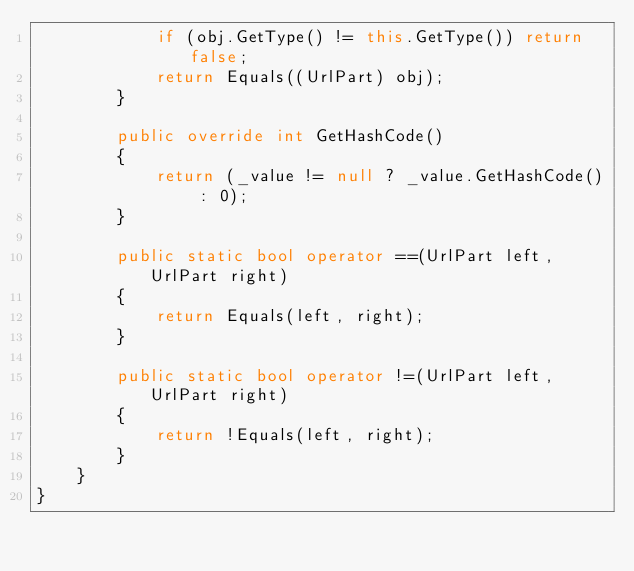<code> <loc_0><loc_0><loc_500><loc_500><_C#_>            if (obj.GetType() != this.GetType()) return false;
            return Equals((UrlPart) obj);
        }

        public override int GetHashCode()
        {
            return (_value != null ? _value.GetHashCode() : 0);
        }

        public static bool operator ==(UrlPart left, UrlPart right)
        {
            return Equals(left, right);
        }

        public static bool operator !=(UrlPart left, UrlPart right)
        {
            return !Equals(left, right);
        }
    }
}</code> 